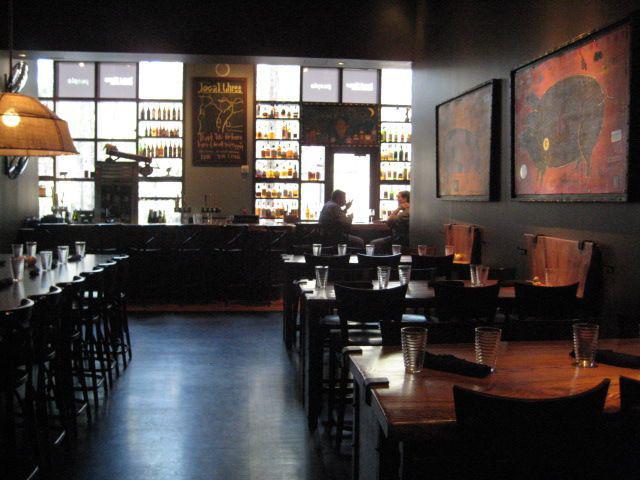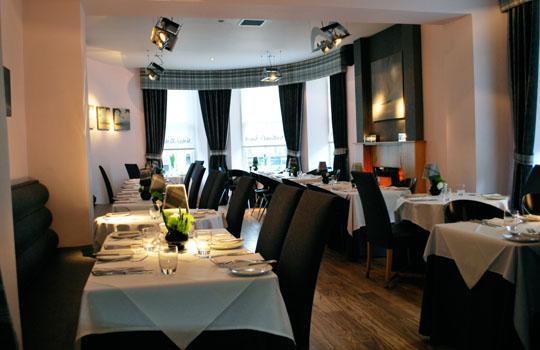The first image is the image on the left, the second image is the image on the right. For the images shown, is this caption "In at least one image there is a single long bar with at least two black hanging lights over it." true? Answer yes or no. No. 